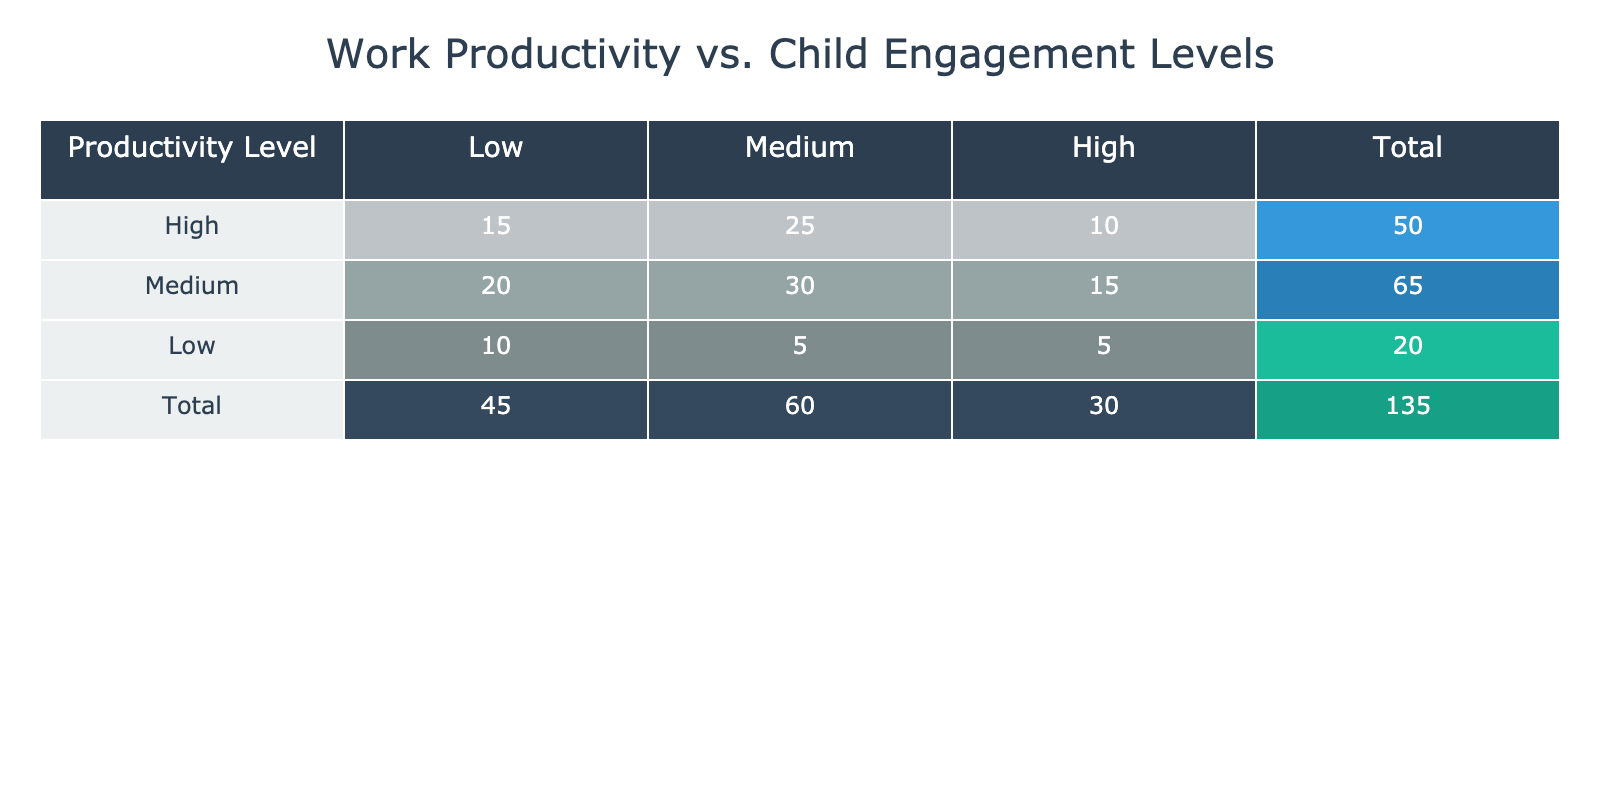What is the count of instances where productivity levels are high and child engagement levels are medium? According to the table, the count for high productivity and medium child engagement is explicitly listed as 25.
Answer: 25 What is the total count of instances when productivity levels are low? To find this, I will sum the counts in the low productivity row. The counts are 10 (low, low) + 5 (low, medium) + 5 (low, high) = 20.
Answer: 20 Is it true that there are more instances of medium productivity than low productivity? The total instances for medium productivity (20 + 30 + 15 = 65) must be compared with low productivity (10 + 5 + 5 = 20). Since 65 is greater than 20, the statement is true.
Answer: Yes What is the difference between the total counts of high and low child engagement levels? First, I sum the counts for high child engagement: 10 (high, high) + 15 (medium, high) + 5 (low, high) = 30. Next, I sum the counts for low child engagement: 15 (high, low) + 20 (medium, low) + 10 (low, low) = 45. The difference is 45 - 30 = 15.
Answer: 15 How many total instances have high productivity and engagement levels combined? I need to sum the counts where both productivity and engagement are high: 10 (high, high) from the table. This total also includes no other case where both are high.
Answer: 10 What is the average count of child engagement levels when productivity is at a medium level? The counts for medium productivity are: 20 (low) + 30 (medium) + 15 (high), which sums to 65. There are 3 child engagement levels, so the average is 65 / 3 = 21.67.
Answer: 21.67 Is there an equal number of instances for low child engagement across all productivity levels? Assessing the counts for low engagement: 10 (high, low), 20 (medium, low), 10 (low, low). Since the numbers differ (10, 20, and 10 respectively), it is false.
Answer: No How many instances are there when both productivity and child engagement levels are at medium? The table shows the count where both levels are medium is 30, hence there are 30 instances.
Answer: 30 